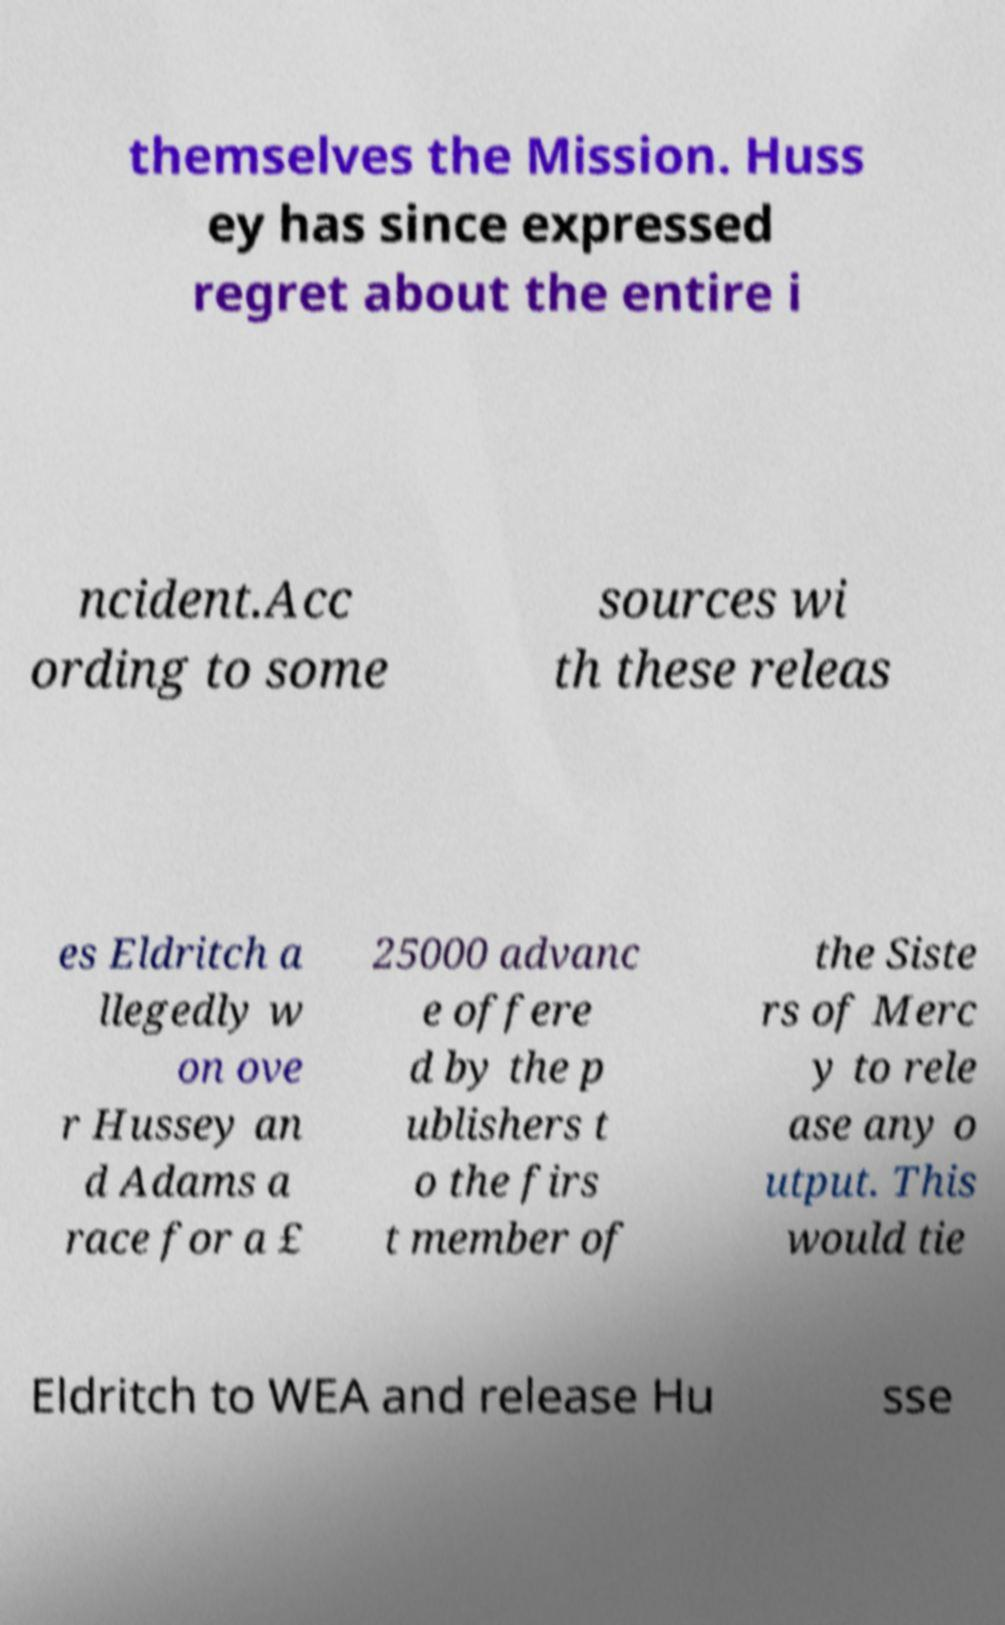I need the written content from this picture converted into text. Can you do that? themselves the Mission. Huss ey has since expressed regret about the entire i ncident.Acc ording to some sources wi th these releas es Eldritch a llegedly w on ove r Hussey an d Adams a race for a £ 25000 advanc e offere d by the p ublishers t o the firs t member of the Siste rs of Merc y to rele ase any o utput. This would tie Eldritch to WEA and release Hu sse 